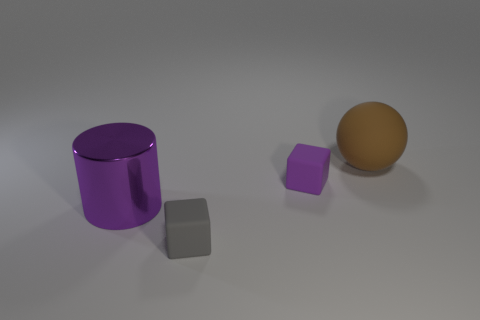Add 1 large purple metallic objects. How many objects exist? 5 Subtract all spheres. How many objects are left? 3 Add 4 tiny gray matte things. How many tiny gray matte things are left? 5 Add 4 blue metallic spheres. How many blue metallic spheres exist? 4 Subtract 0 cyan spheres. How many objects are left? 4 Subtract 1 blocks. How many blocks are left? 1 Subtract all cyan blocks. Subtract all purple cylinders. How many blocks are left? 2 Subtract all blue cylinders. How many cyan blocks are left? 0 Subtract all tiny green shiny cylinders. Subtract all big spheres. How many objects are left? 3 